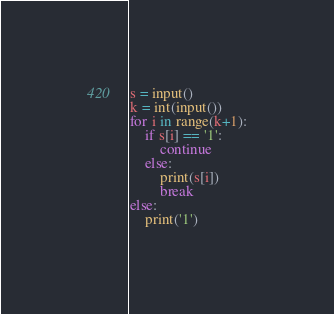Convert code to text. <code><loc_0><loc_0><loc_500><loc_500><_Python_>s = input()
k = int(input())
for i in range(k+1):
    if s[i] == '1':
        continue
    else:
        print(s[i])
        break
else:
    print('1')</code> 